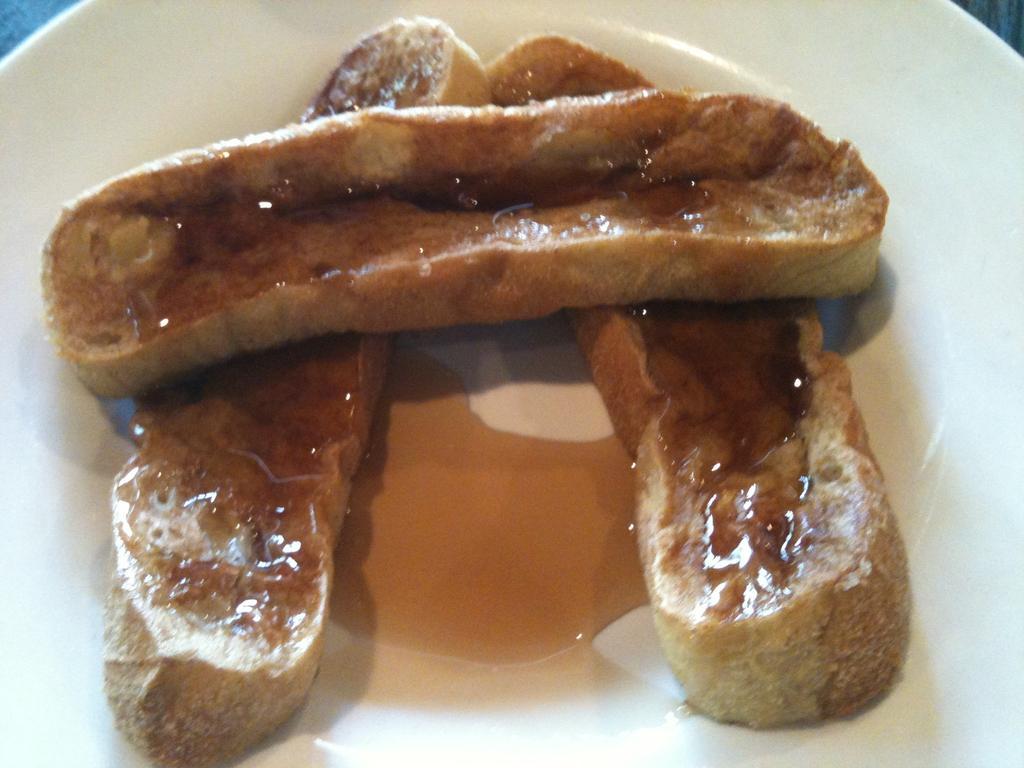Could you give a brief overview of what you see in this image? In this image we can see one plate with some food and the plate is on the surface. 